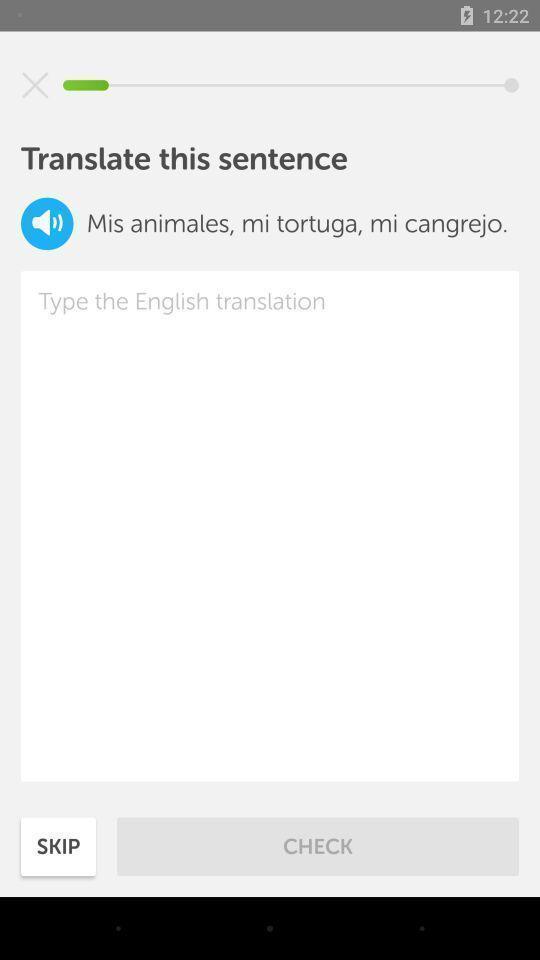Describe this image in words. Screen page of language translator application. 